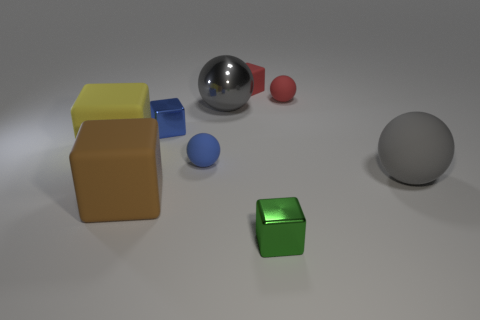What size is the red object on the left side of the metal thing that is right of the gray metallic object?
Give a very brief answer. Small. The big object that is both to the right of the big brown matte block and behind the blue matte ball is made of what material?
Your response must be concise. Metal. What number of other things are the same size as the blue cube?
Make the answer very short. 4. The large shiny ball is what color?
Keep it short and to the point. Gray. There is a large ball behind the yellow matte cube; is its color the same as the ball that is in front of the blue rubber thing?
Keep it short and to the point. Yes. What is the size of the brown thing?
Provide a succinct answer. Large. There is a gray thing that is on the right side of the small green cube; what is its size?
Your answer should be very brief. Large. There is a shiny object that is both behind the large yellow rubber cube and in front of the large gray metallic thing; what shape is it?
Ensure brevity in your answer.  Cube. What number of other things are the same shape as the brown thing?
Offer a terse response. 4. What is the color of the other matte cube that is the same size as the green block?
Make the answer very short. Red. 